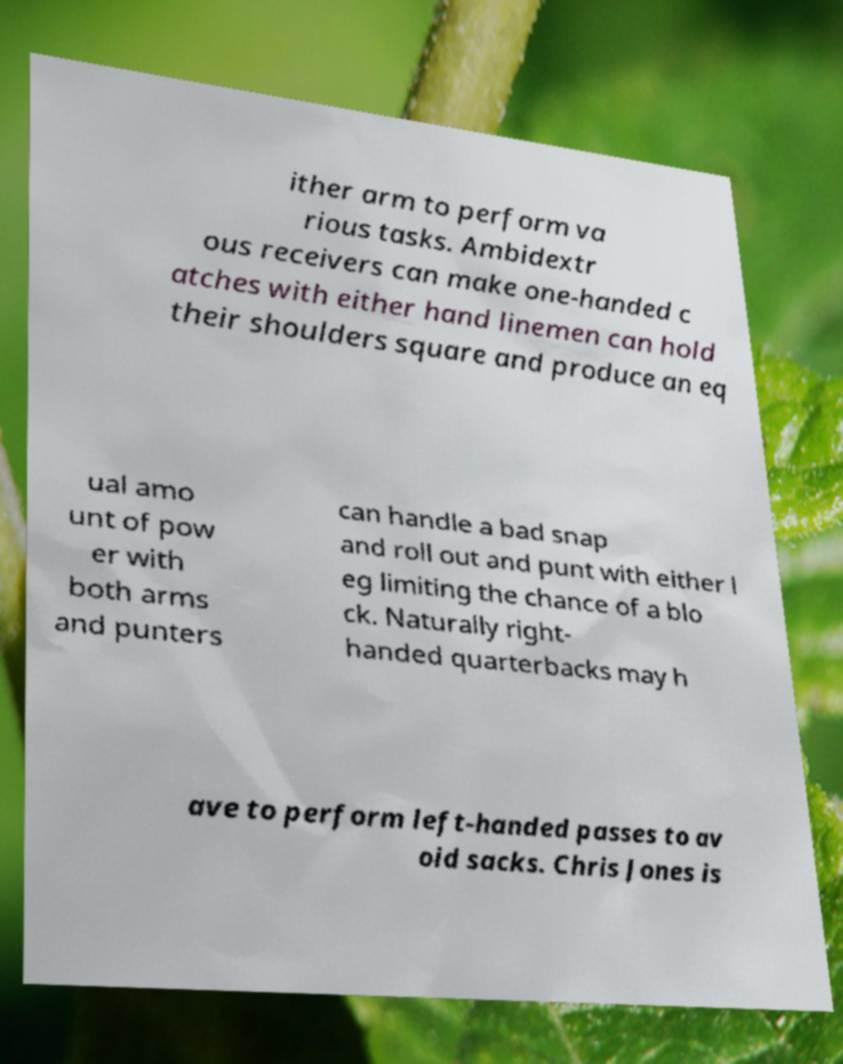Can you accurately transcribe the text from the provided image for me? ither arm to perform va rious tasks. Ambidextr ous receivers can make one-handed c atches with either hand linemen can hold their shoulders square and produce an eq ual amo unt of pow er with both arms and punters can handle a bad snap and roll out and punt with either l eg limiting the chance of a blo ck. Naturally right- handed quarterbacks may h ave to perform left-handed passes to av oid sacks. Chris Jones is 